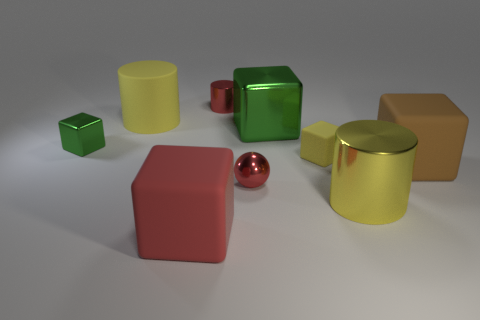What is the composition of the objects like in relation to each other? The composition in the image is well-balanced, with a dynamic range of shapes and sizes. The objects are placed in a manner that gives a sense of depth, with larger objects like the brown and yellow cubes creating a backdrop for the smaller ones like the tiny shiny cylinder and the red geometric shapes. The varying sizes and distances between objects lead to an interesting spatial arrangement that draws the eye across the image. 